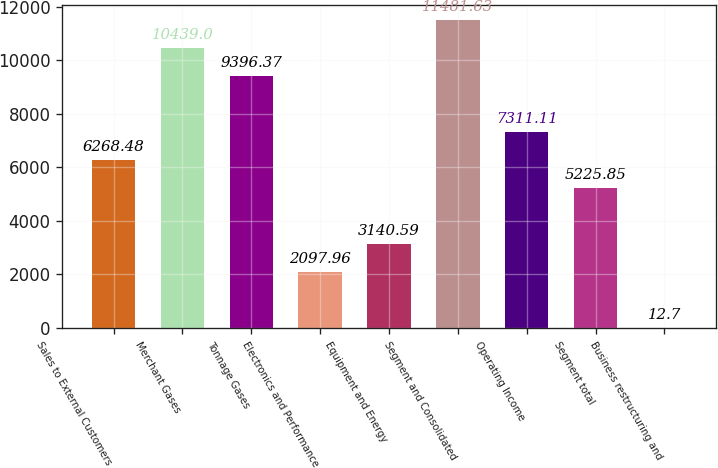Convert chart to OTSL. <chart><loc_0><loc_0><loc_500><loc_500><bar_chart><fcel>Sales to External Customers<fcel>Merchant Gases<fcel>Tonnage Gases<fcel>Electronics and Performance<fcel>Equipment and Energy<fcel>Segment and Consolidated<fcel>Operating Income<fcel>Segment total<fcel>Business restructuring and<nl><fcel>6268.48<fcel>10439<fcel>9396.37<fcel>2097.96<fcel>3140.59<fcel>11481.6<fcel>7311.11<fcel>5225.85<fcel>12.7<nl></chart> 